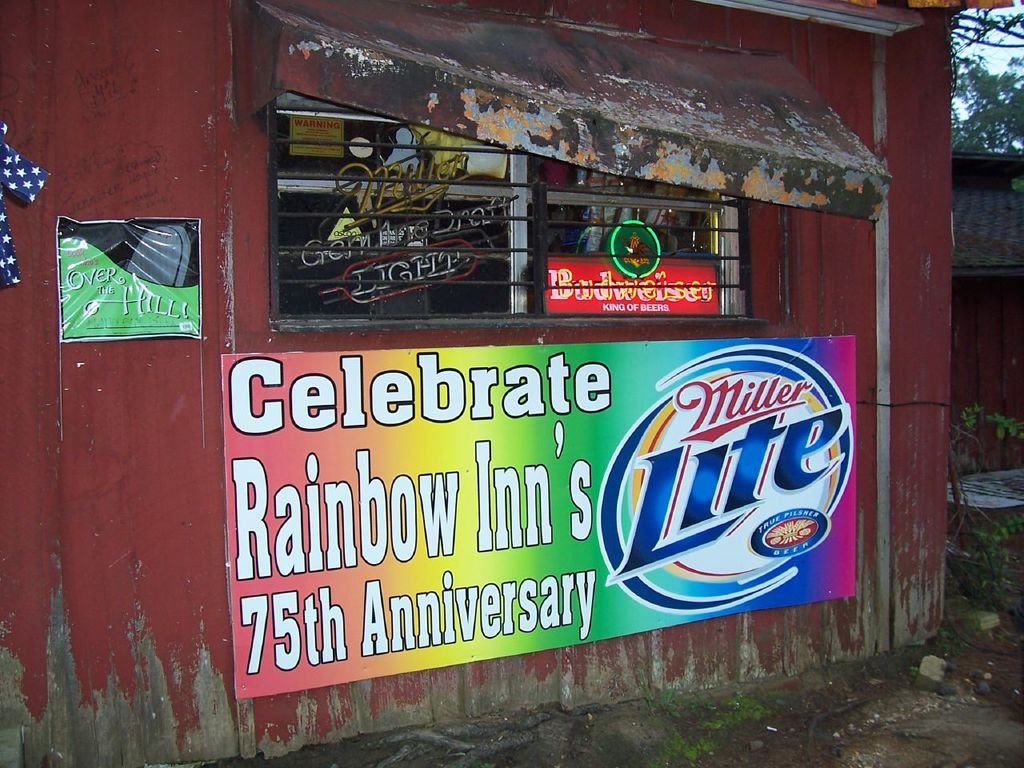Can you tell me more about the architecture of the building and its condition? The building appears to be an older structure with historical value, evidenced by its weathered red paint and wooden siding that show signs of wear and age. The windows are decorated but also hint at the building's aging condition with their rustic frames and protection bars, suggesting it has been well-used and maintained to preserve its original charm amidst the natural surroundings. 